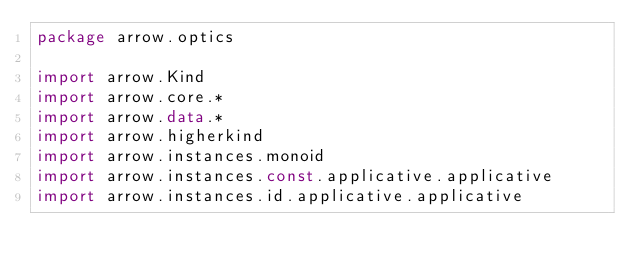Convert code to text. <code><loc_0><loc_0><loc_500><loc_500><_Kotlin_>package arrow.optics

import arrow.Kind
import arrow.core.*
import arrow.data.*
import arrow.higherkind
import arrow.instances.monoid
import arrow.instances.const.applicative.applicative
import arrow.instances.id.applicative.applicative</code> 